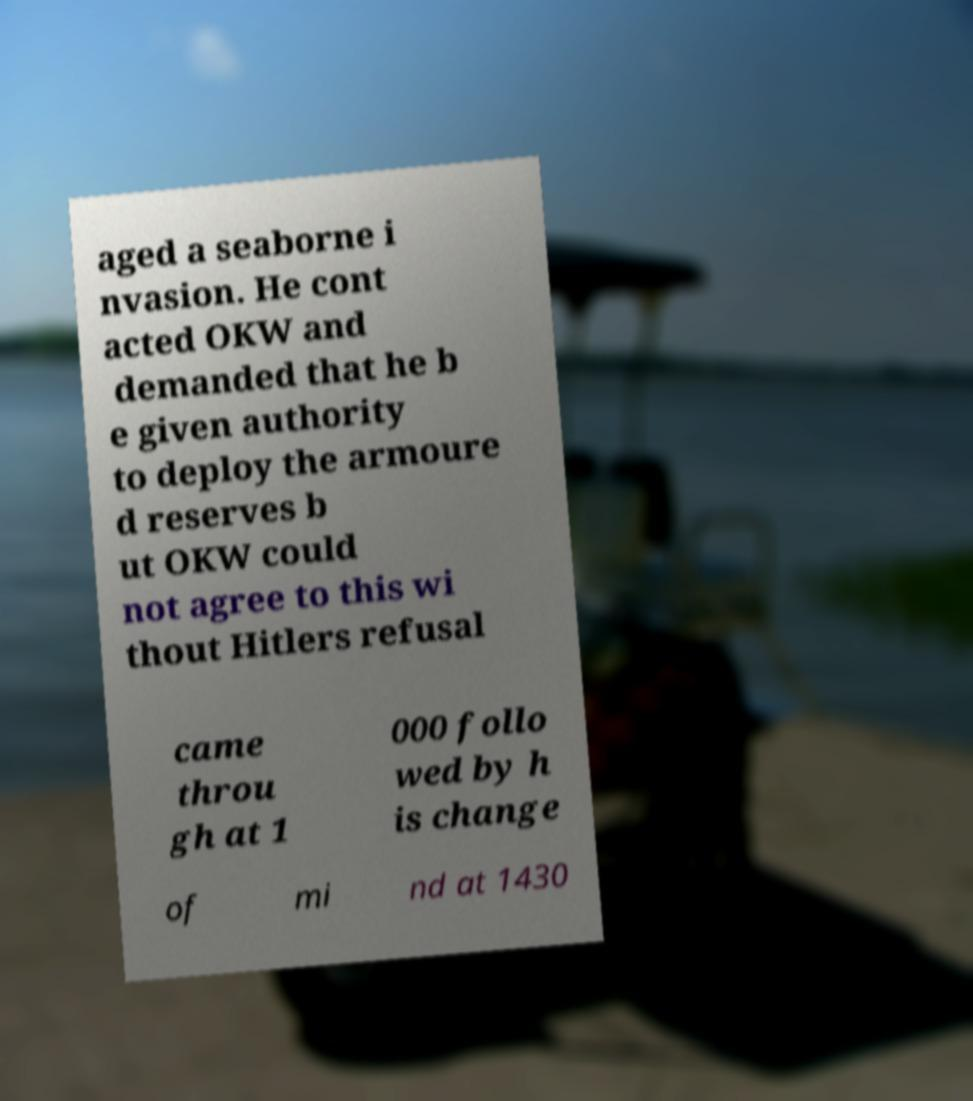Please identify and transcribe the text found in this image. aged a seaborne i nvasion. He cont acted OKW and demanded that he b e given authority to deploy the armoure d reserves b ut OKW could not agree to this wi thout Hitlers refusal came throu gh at 1 000 follo wed by h is change of mi nd at 1430 